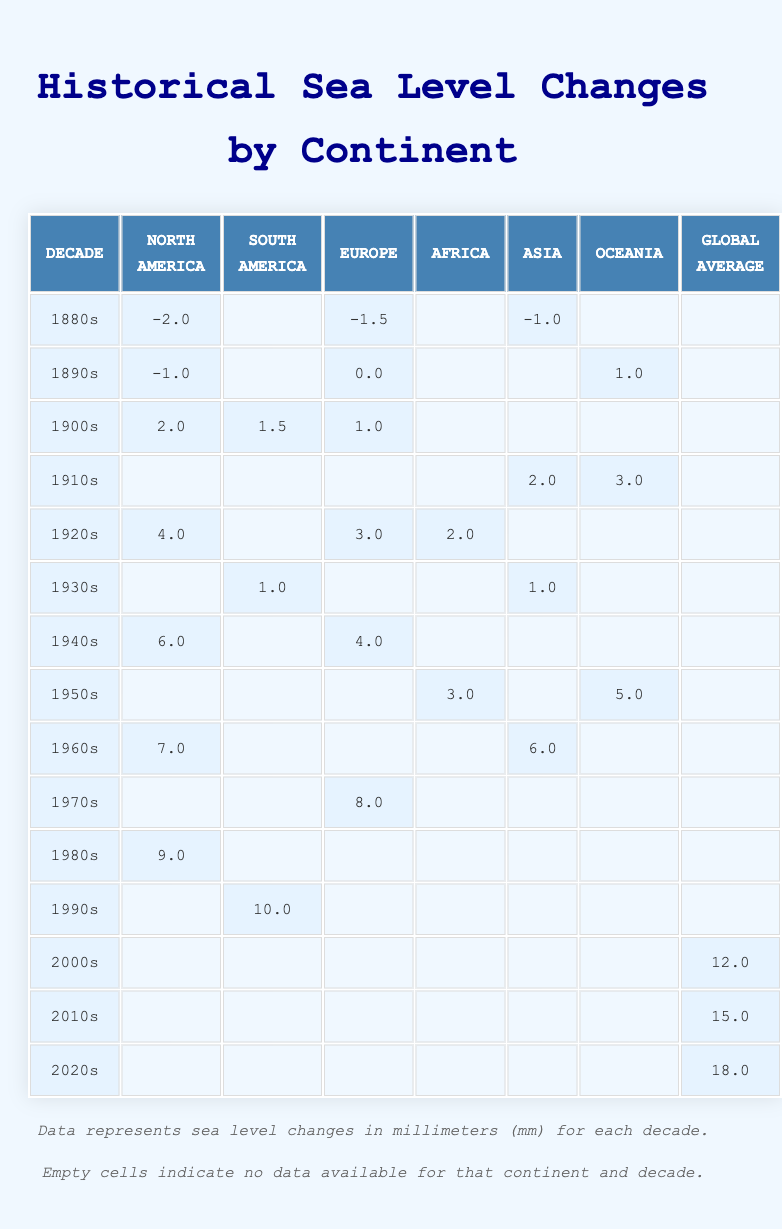What was the sea level change in North America during the 1940s? In the table, the sea level change for North America in the 1940s is directly provided as 6.0 mm.
Answer: 6.0 mm Which continent showed a sea level change of 10.0 mm in the 1990s? The 1990s row shows that South America had a sea level change of 10.0 mm.
Answer: South America What is the difference between the sea level changes in the 1980s and 1970s for Europe? The 1980s row shows no change for Europe (empty), while the 1970s shows a change of 8.0 mm. Therefore, the difference is 0 - 8.0 = -8.0 mm.
Answer: -8.0 mm During which decade did global average sea levels change the most? The global average sea level changes are 12.0 mm in the 2000s, 15.0 mm in the 2010s, and 18.0 mm in the 2020s. The 2020s saw the highest change at 18.0 mm.
Answer: 2020s Was there any average sea level change for South America in the 1880s? The data shows that South America has an empty cell in the 1880s row, indicating no recorded change.
Answer: No What are the average sea level changes for North America across the decades listed? The values for North America across the decades are: -2.0, -1.0, 2.0, 4.0, 6.0, 7.0, 9.0. Summing them gives a total of 25.0 mm, and with 7 data points, the average is 25.0 mm / 7 ≈ 3.57 mm.
Answer: ≈ 3.57 mm On average, which continent had the greatest sea level change in the 1960s? In the 1960s, North America had a change of 7.0 mm and Asia had a change of 6.0 mm. Thus, North America had the greater average change of 7.0 mm.
Answer: North America How many decades did North America experience a negative sea level change? The data indicates that North America had negative changes in the 1880s (-2.0 mm) and the 1890s (-1.0 mm), totaling two decades with negative sea level changes.
Answer: 2 decades What was the total sea level change for Europe from the 1900s to the 1940s? The sea level changes for Europe during those decades are 1.0 mm (1900s), 3.0 mm (1920s), 4.0 mm (1940s). Summing these gives: 1.0 + 3.0 + 4.0 = 8.0 mm.
Answer: 8.0 mm Did Oceania have a sea level increase throughout all decades? Upon reviewing, Oceania had sea level changes of 1.0 mm (1890s), 3.0 mm (1910s), and 5.0 mm (1950s). However, there are empty cells in other decades where no data is provided. Thus, we cannot conclusively state a consistent increase.
Answer: No 